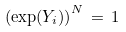Convert formula to latex. <formula><loc_0><loc_0><loc_500><loc_500>\left ( \exp ( Y _ { i } ) \right ) ^ { N } \, = \, 1</formula> 